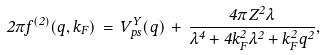<formula> <loc_0><loc_0><loc_500><loc_500>2 { \pi } f ^ { ( 2 ) } ( q , k _ { F } ) \, = \, V ^ { Y } _ { p s } ( q ) \, + \, \frac { 4 { \pi } Z ^ { 2 } { \lambda } } { { \lambda } ^ { 4 } + 4 k _ { F } ^ { 2 } { \lambda } ^ { 2 } + k _ { F } ^ { 2 } q ^ { 2 } } ,</formula> 